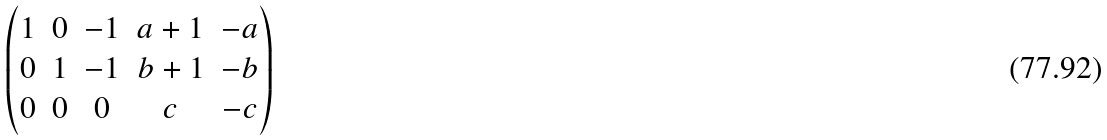<formula> <loc_0><loc_0><loc_500><loc_500>\begin{pmatrix} 1 & 0 & - 1 & a + 1 & - a \\ 0 & 1 & - 1 & b + 1 & - b \\ 0 & 0 & 0 & c & - c \\ \end{pmatrix}</formula> 